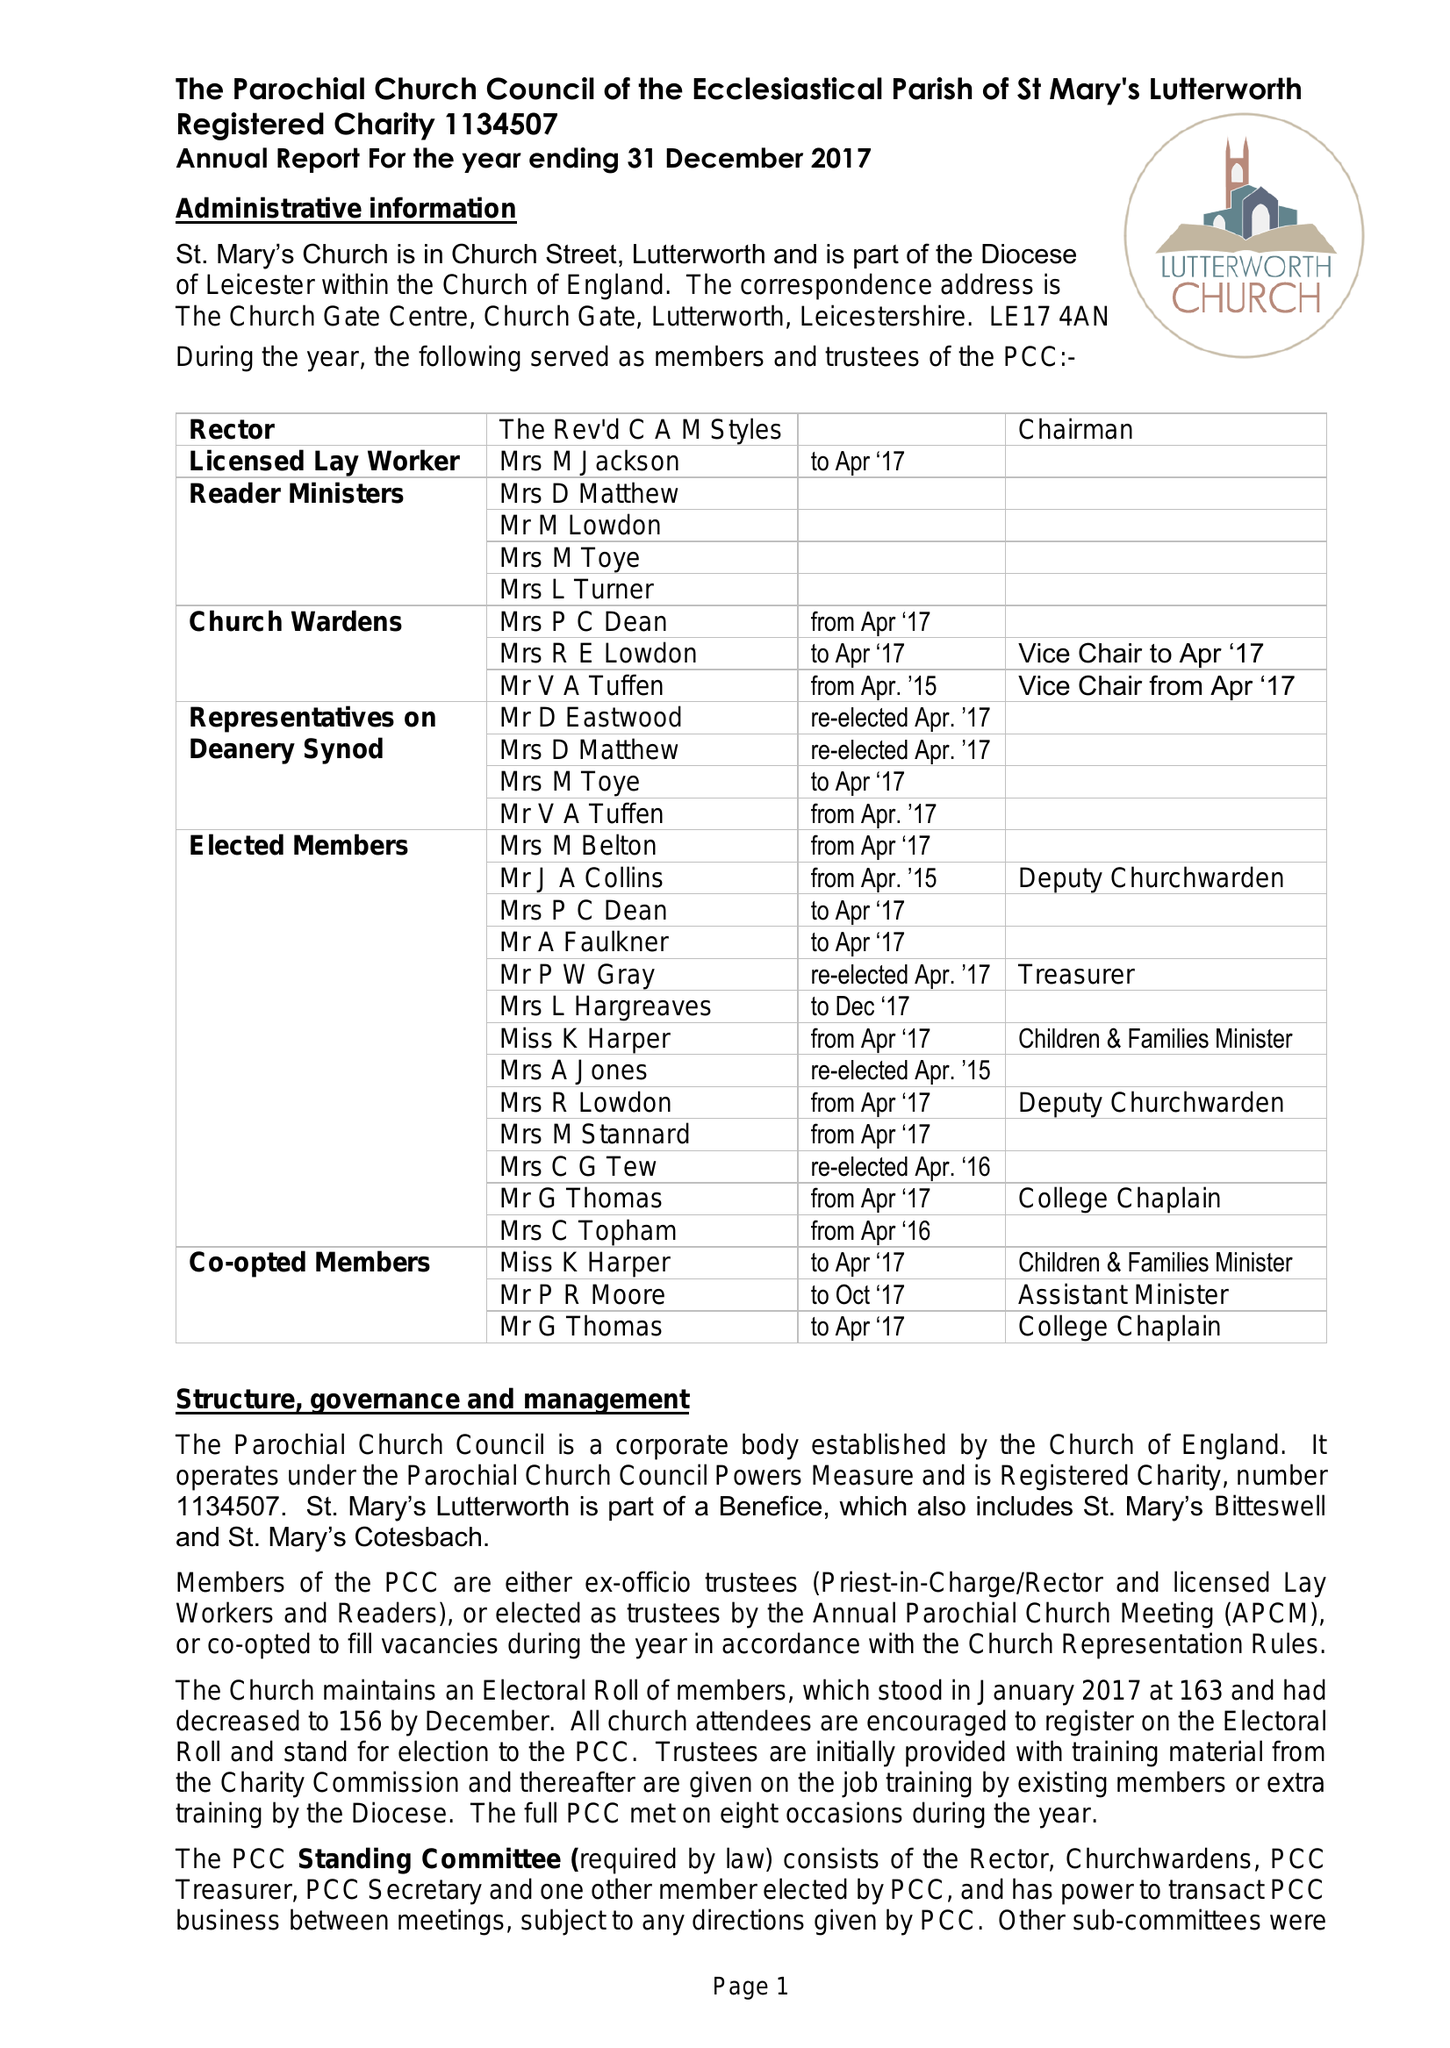What is the value for the spending_annually_in_british_pounds?
Answer the question using a single word or phrase. 258767.00 